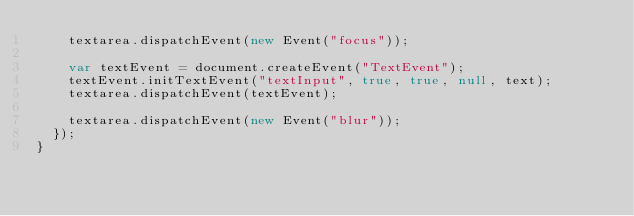Convert code to text. <code><loc_0><loc_0><loc_500><loc_500><_JavaScript_>    textarea.dispatchEvent(new Event("focus"));

    var textEvent = document.createEvent("TextEvent");
    textEvent.initTextEvent("textInput", true, true, null, text);
    textarea.dispatchEvent(textEvent);

    textarea.dispatchEvent(new Event("blur"));
  });
}
</code> 